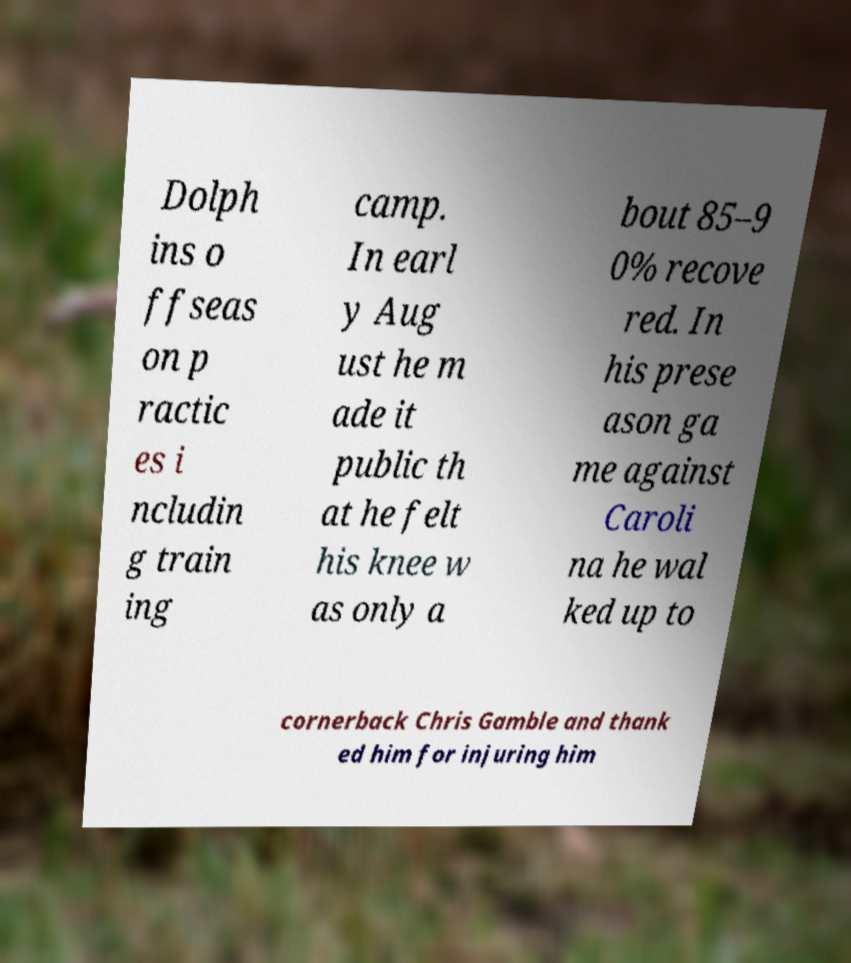Please read and relay the text visible in this image. What does it say? Dolph ins o ffseas on p ractic es i ncludin g train ing camp. In earl y Aug ust he m ade it public th at he felt his knee w as only a bout 85–9 0% recove red. In his prese ason ga me against Caroli na he wal ked up to cornerback Chris Gamble and thank ed him for injuring him 